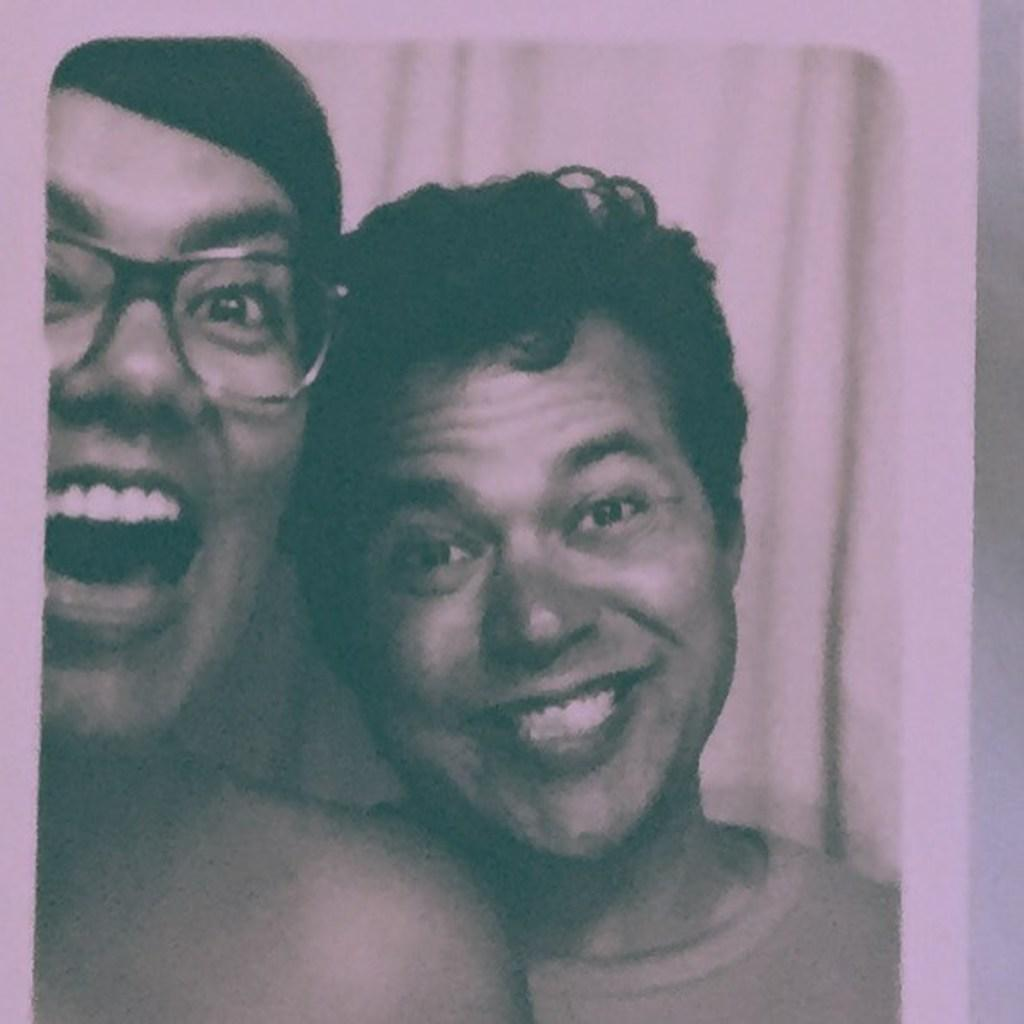How many people are present in the image? There are two persons in the image. What can be seen in the background or surrounding the persons? There is a curtain in the image. What color is the paint on the sidewalk in the image? There is no sidewalk present in the image, so it is not possible to determine the color of any paint on it. 